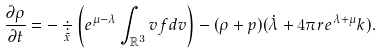Convert formula to latex. <formula><loc_0><loc_0><loc_500><loc_500>\frac { \partial \rho } { \partial t } = - \underset { \tilde { x } } { \div } \left ( e ^ { \mu - \lambda } \int _ { \mathbb { R } ^ { 3 } } v f d v \right ) - ( \rho + p ) ( \dot { \lambda } + 4 \pi r e ^ { \lambda + \mu } k ) .</formula> 